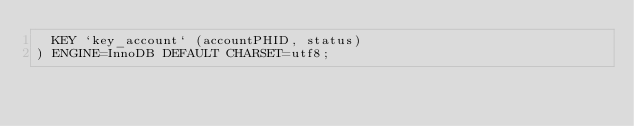<code> <loc_0><loc_0><loc_500><loc_500><_SQL_>  KEY `key_account` (accountPHID, status)
) ENGINE=InnoDB DEFAULT CHARSET=utf8;
</code> 